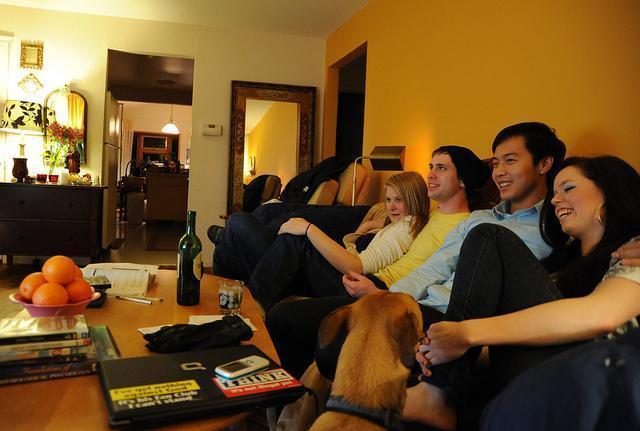How many people are on the couch?
Give a very brief answer. 4. How many people have boxes on their laps?
Give a very brief answer. 0. How many oranges are in the bowl?
Give a very brief answer. 5. How many books are there?
Give a very brief answer. 2. How many people are there?
Give a very brief answer. 4. How many cats do you see?
Give a very brief answer. 0. 